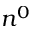<formula> <loc_0><loc_0><loc_500><loc_500>n ^ { 0 }</formula> 